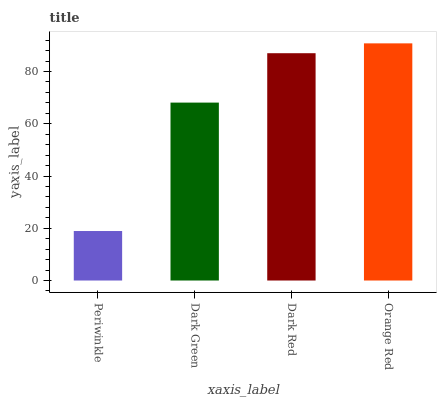Is Periwinkle the minimum?
Answer yes or no. Yes. Is Orange Red the maximum?
Answer yes or no. Yes. Is Dark Green the minimum?
Answer yes or no. No. Is Dark Green the maximum?
Answer yes or no. No. Is Dark Green greater than Periwinkle?
Answer yes or no. Yes. Is Periwinkle less than Dark Green?
Answer yes or no. Yes. Is Periwinkle greater than Dark Green?
Answer yes or no. No. Is Dark Green less than Periwinkle?
Answer yes or no. No. Is Dark Red the high median?
Answer yes or no. Yes. Is Dark Green the low median?
Answer yes or no. Yes. Is Periwinkle the high median?
Answer yes or no. No. Is Periwinkle the low median?
Answer yes or no. No. 